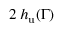<formula> <loc_0><loc_0><loc_500><loc_500>2 \, h _ { u } ( \Gamma )</formula> 